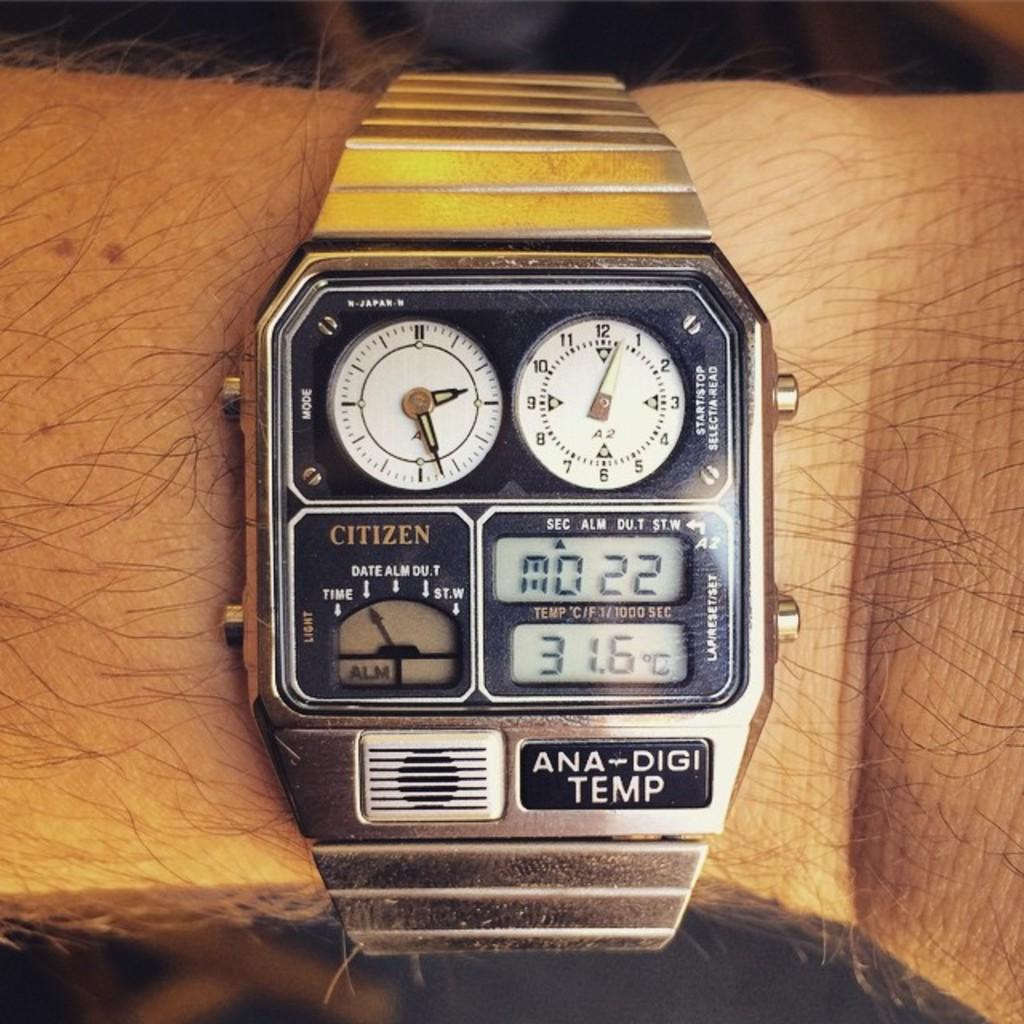<image>
Summarize the visual content of the image. A Citizen brand watch shows the temperature of 31.6 degrees C. 